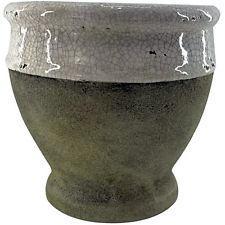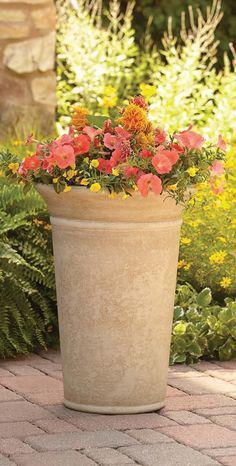The first image is the image on the left, the second image is the image on the right. Given the left and right images, does the statement "Each image contains one empty urn, and one of the urn models is footed, with a pedestal base." hold true? Answer yes or no. No. The first image is the image on the left, the second image is the image on the right. Evaluate the accuracy of this statement regarding the images: "In one image, a flowering plant is shown in a tall planter pot outside". Is it true? Answer yes or no. Yes. 